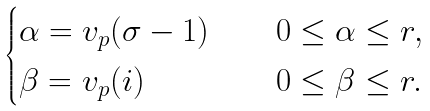Convert formula to latex. <formula><loc_0><loc_0><loc_500><loc_500>\begin{cases} \alpha = v _ { p } ( \sigma - 1 ) \quad & 0 \leq \alpha \leq r , \\ \beta = v _ { p } ( i ) \quad & 0 \leq \beta \leq r . \\ \end{cases}</formula> 